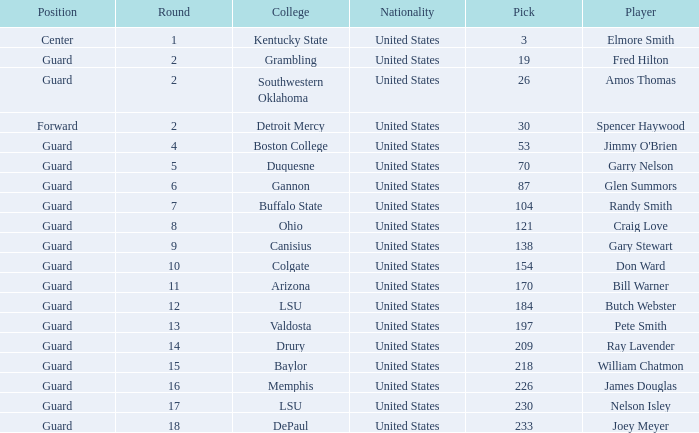WHAT POSITION HAS A ROUND LARGER THAN 2, FOR VALDOSTA COLLEGE? Guard. 